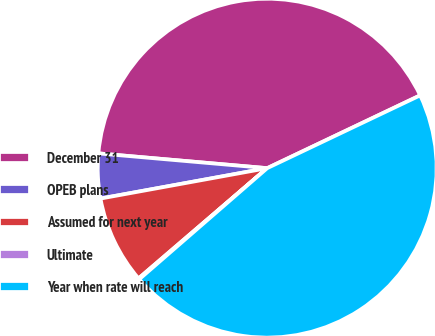Convert chart to OTSL. <chart><loc_0><loc_0><loc_500><loc_500><pie_chart><fcel>December 31<fcel>OPEB plans<fcel>Assumed for next year<fcel>Ultimate<fcel>Year when rate will reach<nl><fcel>41.54%<fcel>4.26%<fcel>8.41%<fcel>0.1%<fcel>45.69%<nl></chart> 